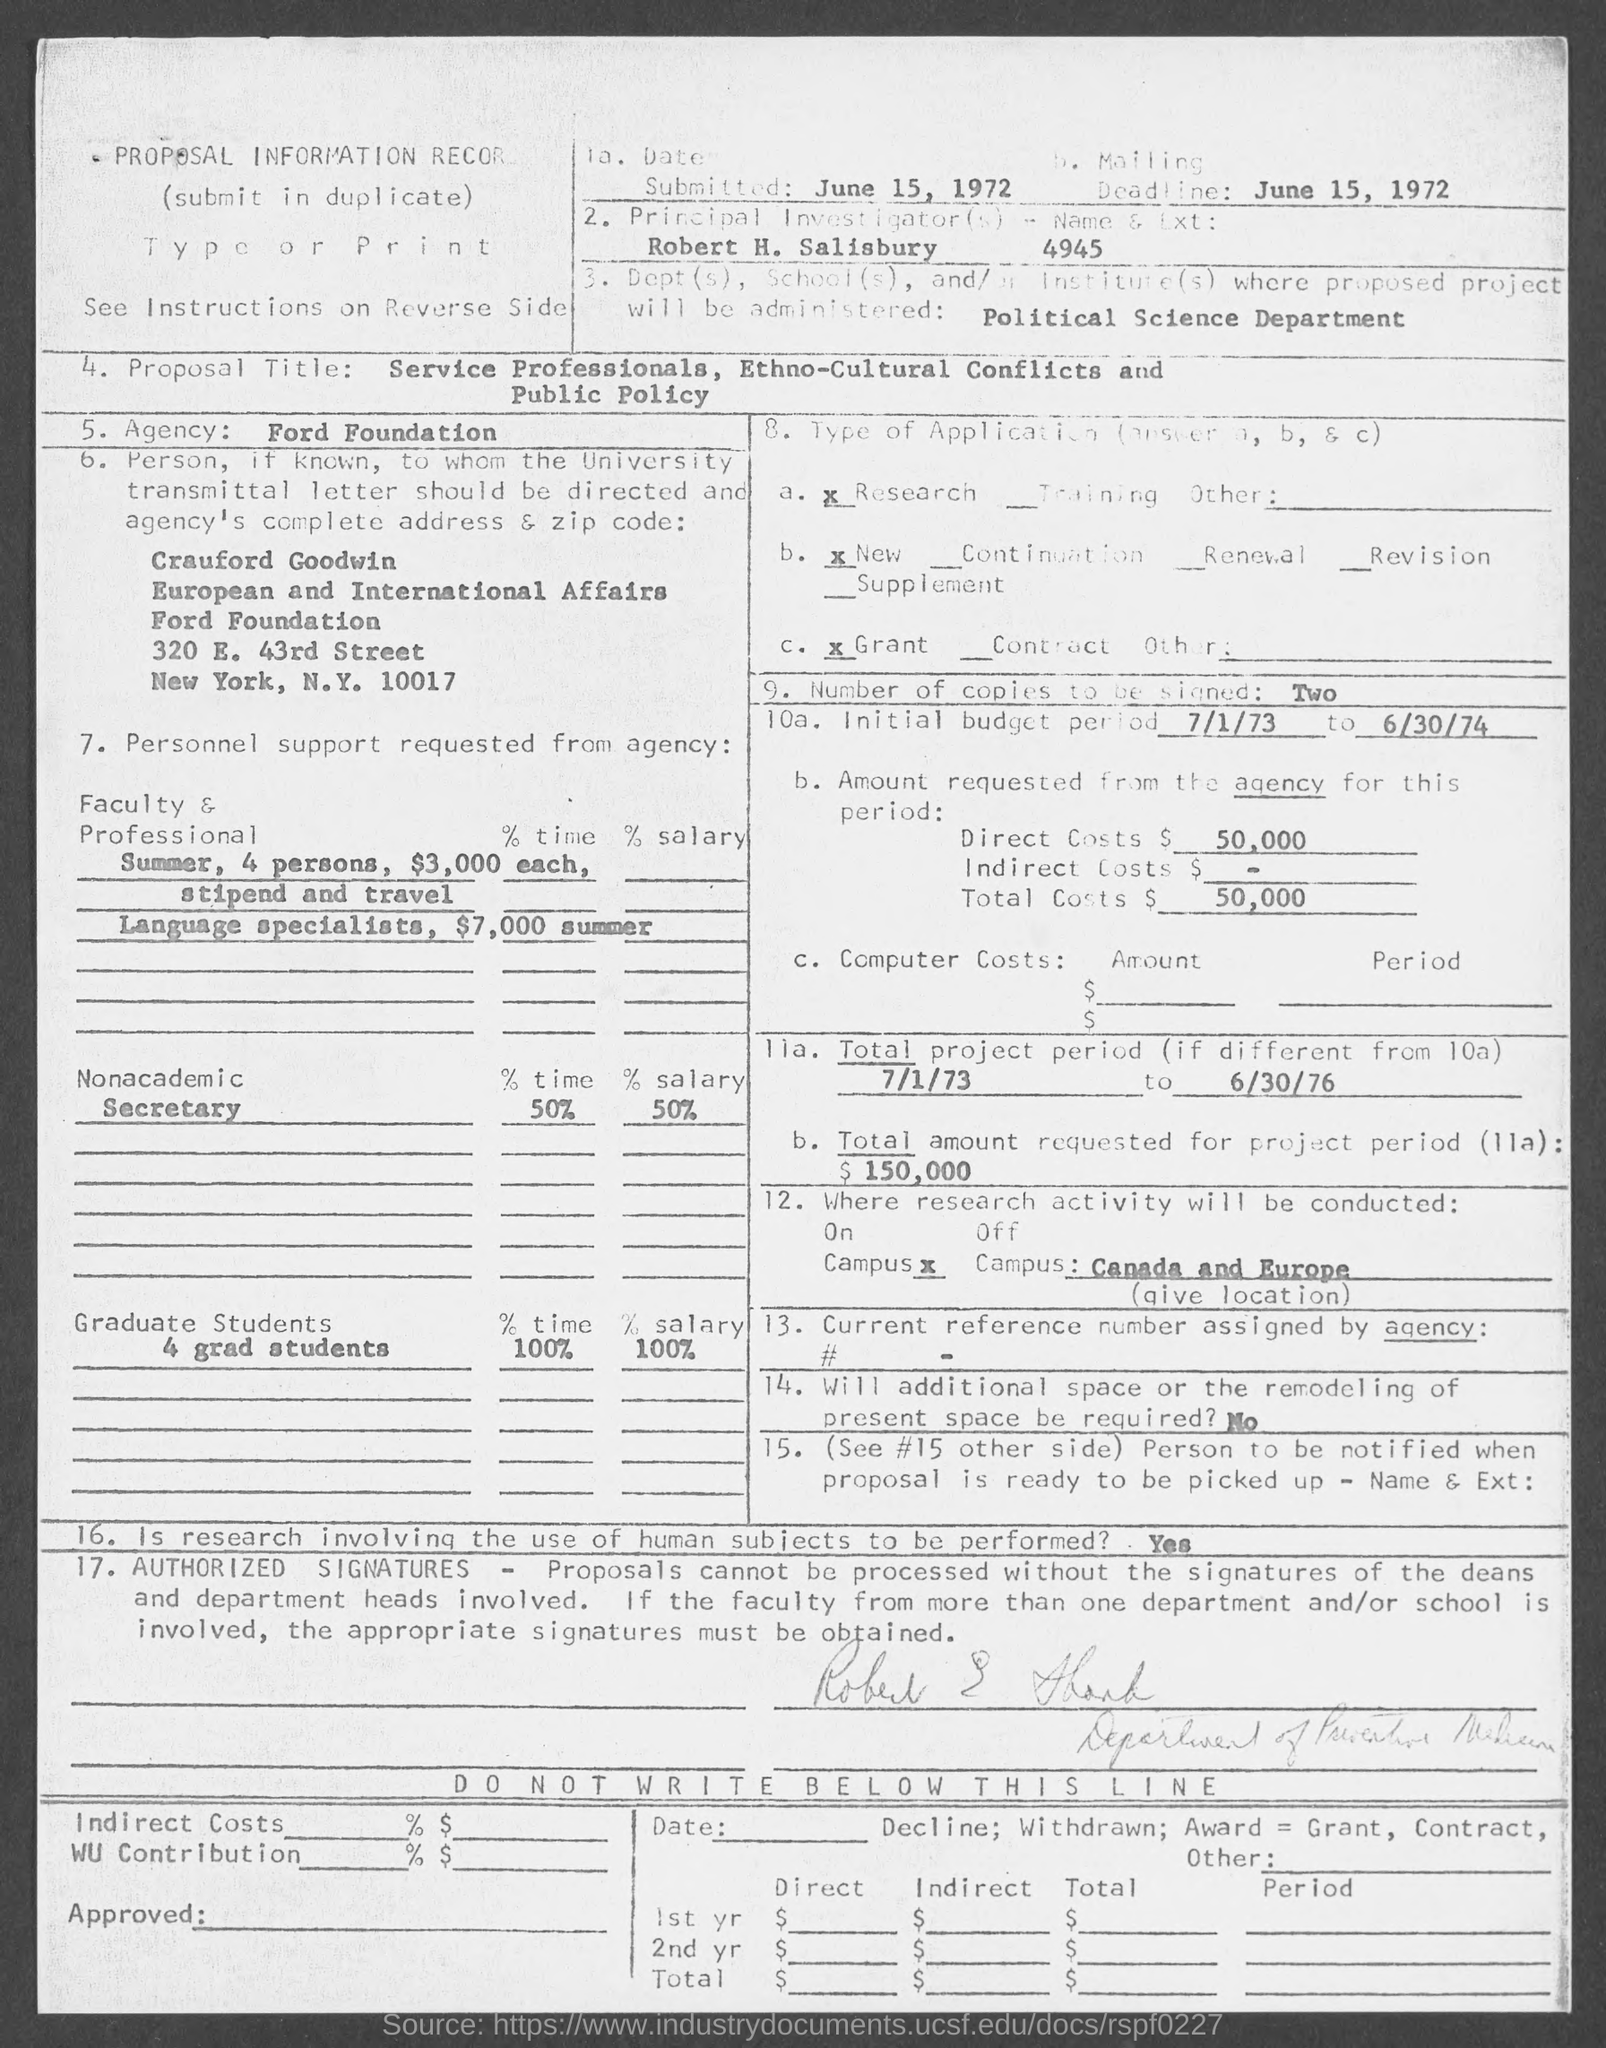Mention a couple of crucial points in this snapshot. The initial budget period is from July 1, 1973 to June 30, 1974. The zip code is 10017. The direct costs amount to 50,000. 